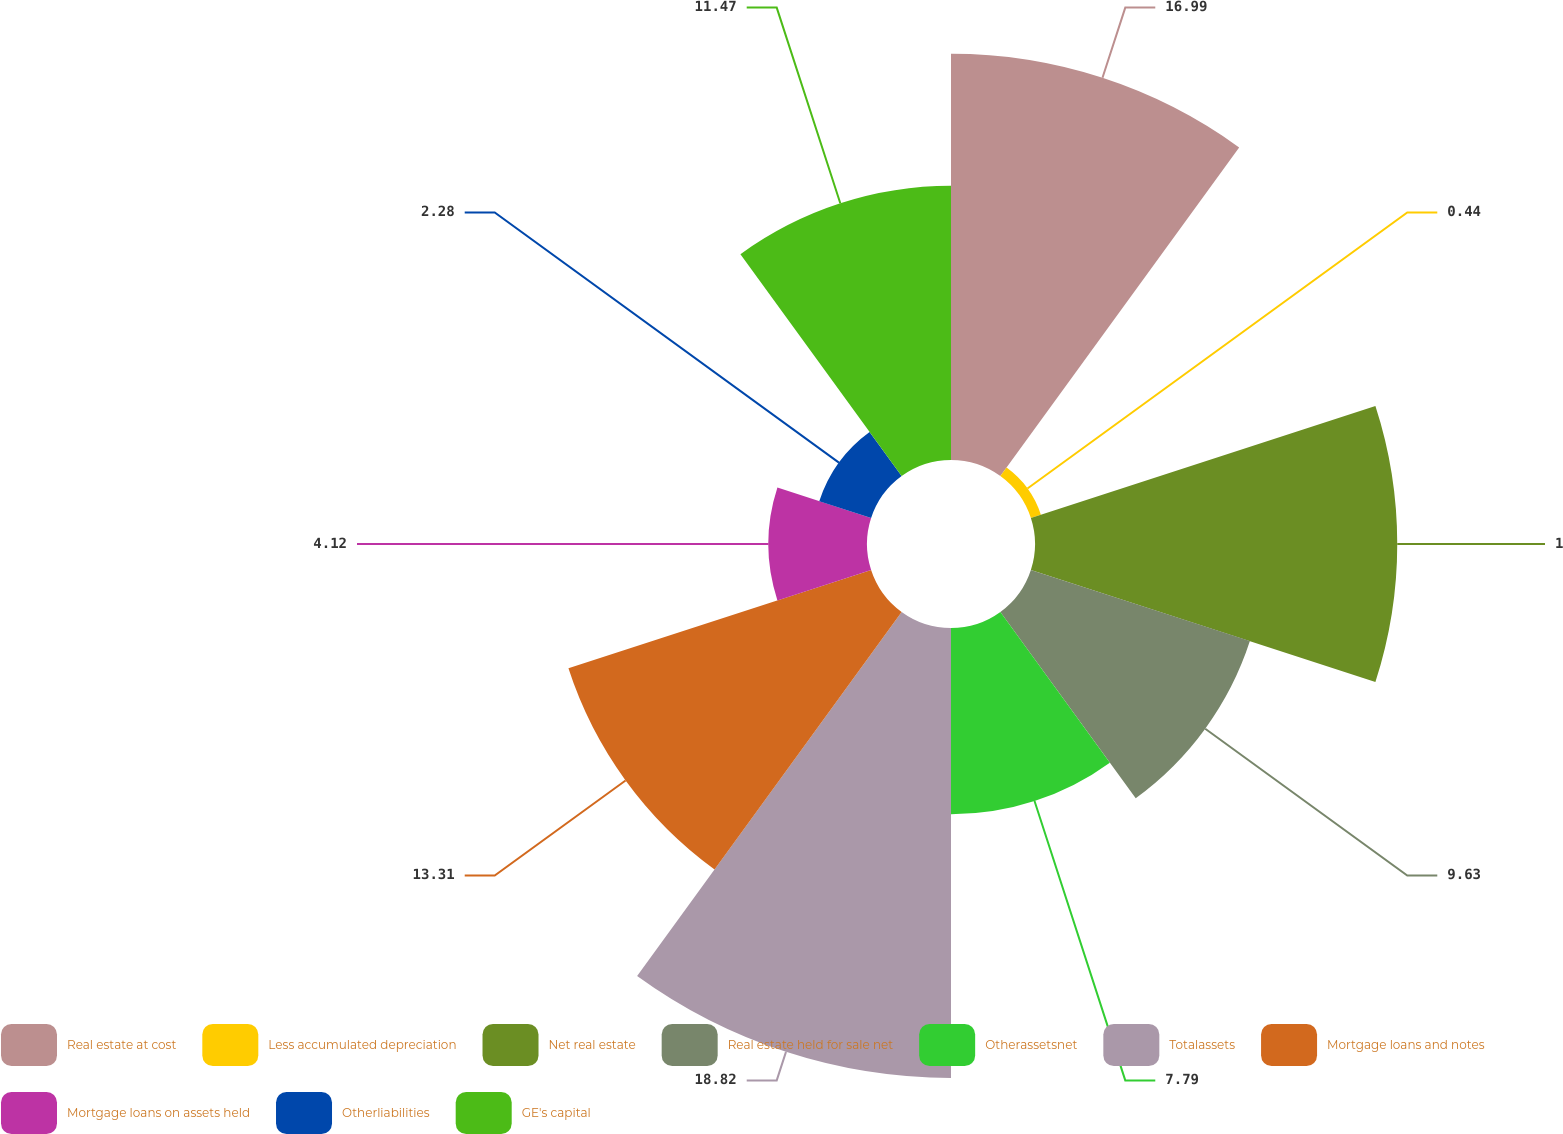Convert chart. <chart><loc_0><loc_0><loc_500><loc_500><pie_chart><fcel>Real estate at cost<fcel>Less accumulated depreciation<fcel>Net real estate<fcel>Real estate held for sale net<fcel>Otherassetsnet<fcel>Totalassets<fcel>Mortgage loans and notes<fcel>Mortgage loans on assets held<fcel>Otherliabilities<fcel>GE's capital<nl><fcel>16.99%<fcel>0.44%<fcel>15.15%<fcel>9.63%<fcel>7.79%<fcel>18.82%<fcel>13.31%<fcel>4.12%<fcel>2.28%<fcel>11.47%<nl></chart> 